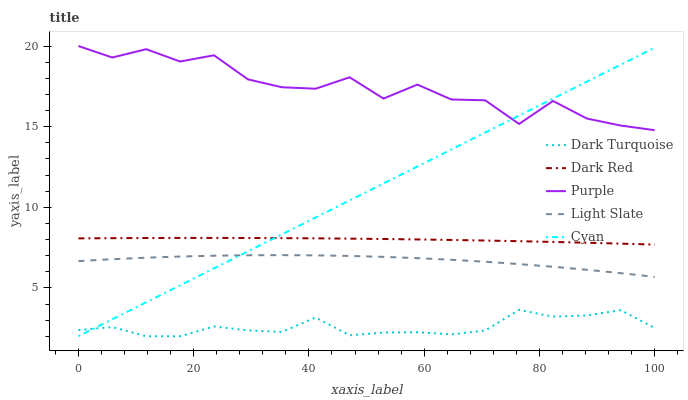Does Dark Turquoise have the minimum area under the curve?
Answer yes or no. Yes. Does Purple have the maximum area under the curve?
Answer yes or no. Yes. Does Cyan have the minimum area under the curve?
Answer yes or no. No. Does Cyan have the maximum area under the curve?
Answer yes or no. No. Is Cyan the smoothest?
Answer yes or no. Yes. Is Purple the roughest?
Answer yes or no. Yes. Is Dark Turquoise the smoothest?
Answer yes or no. No. Is Dark Turquoise the roughest?
Answer yes or no. No. Does Dark Turquoise have the lowest value?
Answer yes or no. Yes. Does Light Slate have the lowest value?
Answer yes or no. No. Does Purple have the highest value?
Answer yes or no. Yes. Does Cyan have the highest value?
Answer yes or no. No. Is Light Slate less than Purple?
Answer yes or no. Yes. Is Purple greater than Light Slate?
Answer yes or no. Yes. Does Light Slate intersect Cyan?
Answer yes or no. Yes. Is Light Slate less than Cyan?
Answer yes or no. No. Is Light Slate greater than Cyan?
Answer yes or no. No. Does Light Slate intersect Purple?
Answer yes or no. No. 